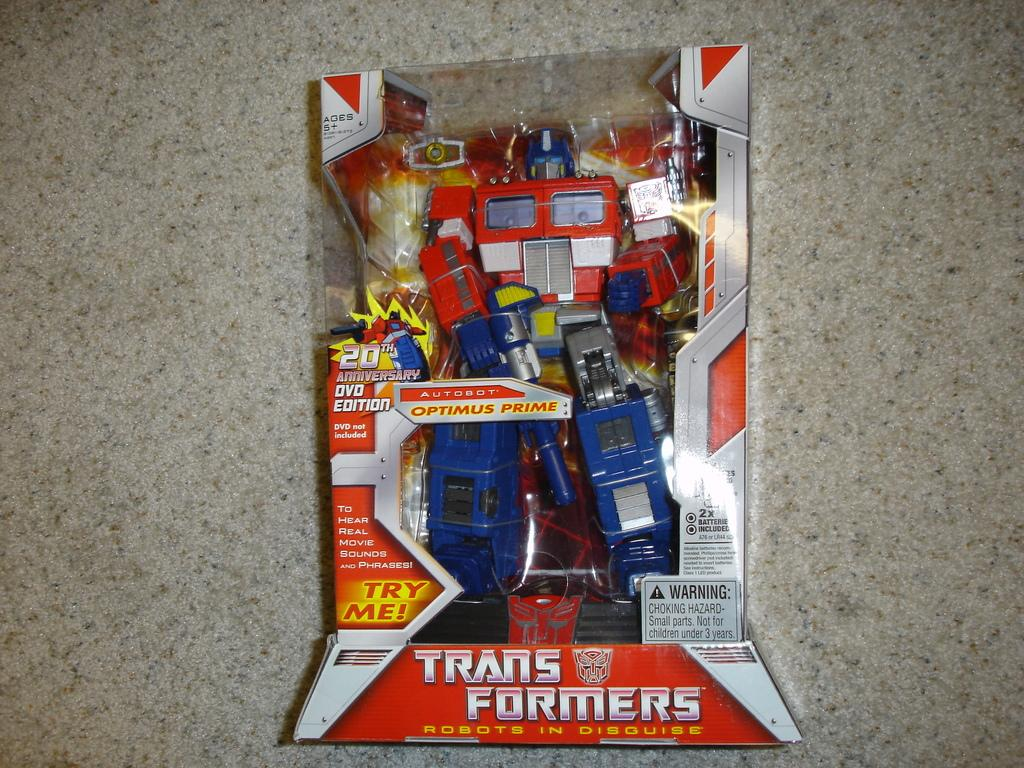<image>
Give a short and clear explanation of the subsequent image. Transformers toy with the words "Try Me!" near the bottom. 